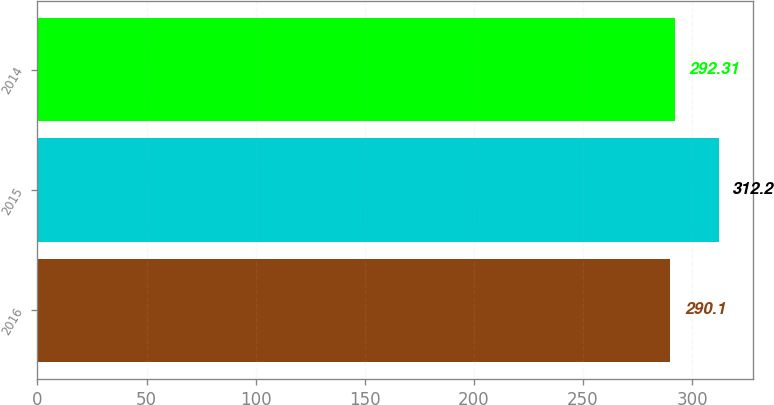<chart> <loc_0><loc_0><loc_500><loc_500><bar_chart><fcel>2016<fcel>2015<fcel>2014<nl><fcel>290.1<fcel>312.2<fcel>292.31<nl></chart> 